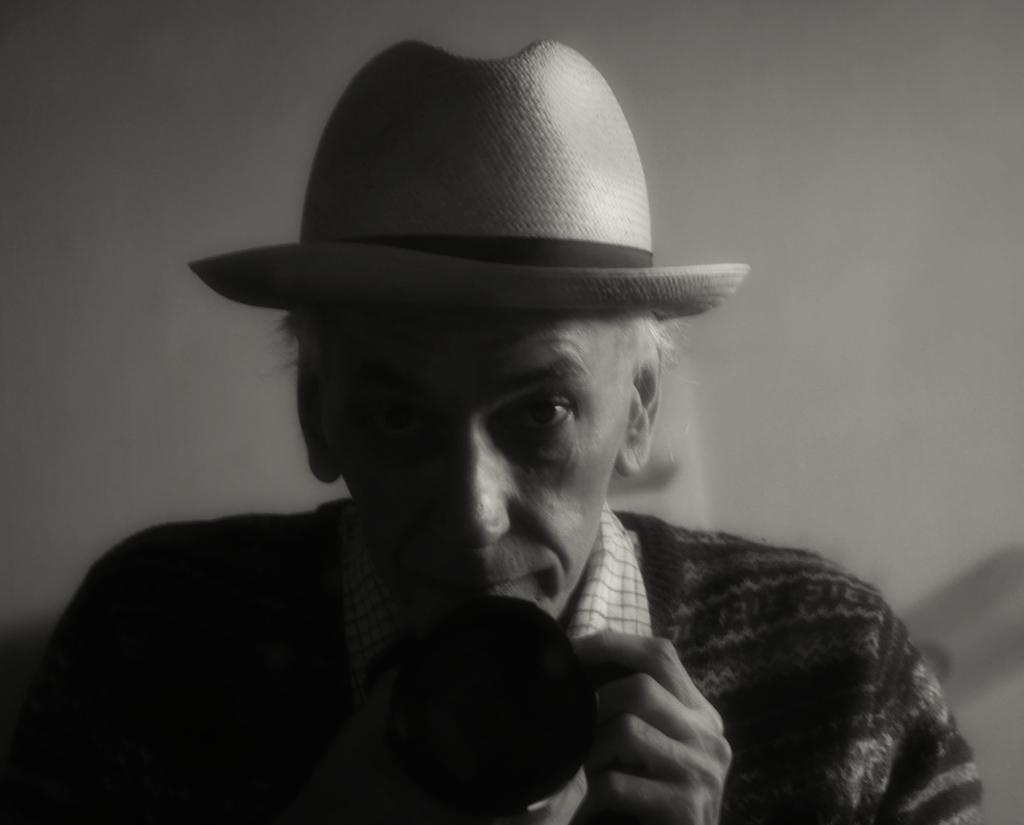What is the color scheme of the image? The image is black and white. Can you describe the person in the image? There is a person in the image, and they are wearing a hat and a shirt. What is the person holding in their hand? The person is holding something in their hand, but the specific object is not mentioned in the facts. How many eggs are being burned by the person in the image? There are no eggs or any indication of burning in the image. What is the person's income based on the image? There is no information about the person's income in the image. 